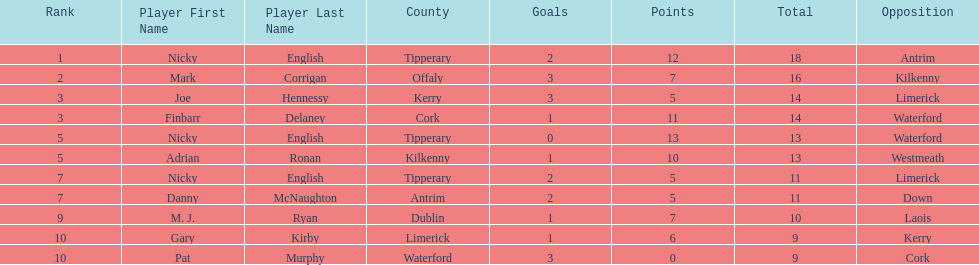Who ranked above mark corrigan? Nicky English. 